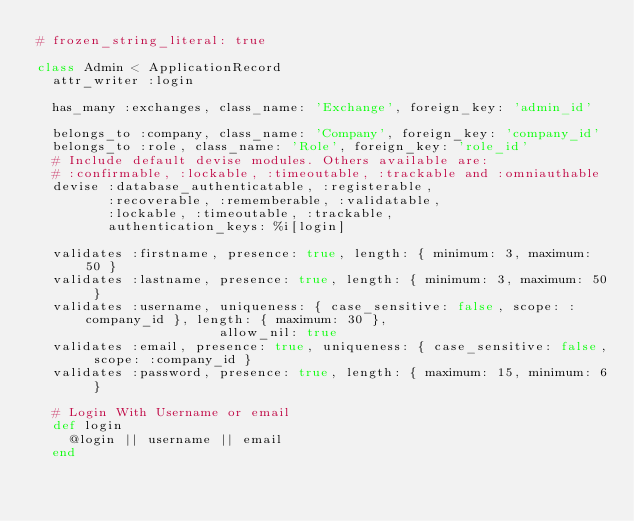<code> <loc_0><loc_0><loc_500><loc_500><_Ruby_># frozen_string_literal: true

class Admin < ApplicationRecord
  attr_writer :login

  has_many :exchanges, class_name: 'Exchange', foreign_key: 'admin_id'

  belongs_to :company, class_name: 'Company', foreign_key: 'company_id'
  belongs_to :role, class_name: 'Role', foreign_key: 'role_id'
  # Include default devise modules. Others available are:
  # :confirmable, :lockable, :timeoutable, :trackable and :omniauthable
  devise :database_authenticatable, :registerable,
         :recoverable, :rememberable, :validatable,
         :lockable, :timeoutable, :trackable,
         authentication_keys: %i[login]

  validates :firstname, presence: true, length: { minimum: 3, maximum: 50 }
  validates :lastname, presence: true, length: { minimum: 3, maximum: 50 }
  validates :username, uniqueness: { case_sensitive: false, scope: :company_id }, length: { maximum: 30 },
                       allow_nil: true
  validates :email, presence: true, uniqueness: { case_sensitive: false, scope: :company_id }
  validates :password, presence: true, length: { maximum: 15, minimum: 6 }

  # Login With Username or email
  def login
    @login || username || email
  end
</code> 